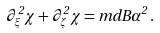<formula> <loc_0><loc_0><loc_500><loc_500>\partial _ { \xi } ^ { 2 } \chi + \partial _ { \zeta } ^ { 2 } \chi = m d B \alpha ^ { 2 } \, .</formula> 